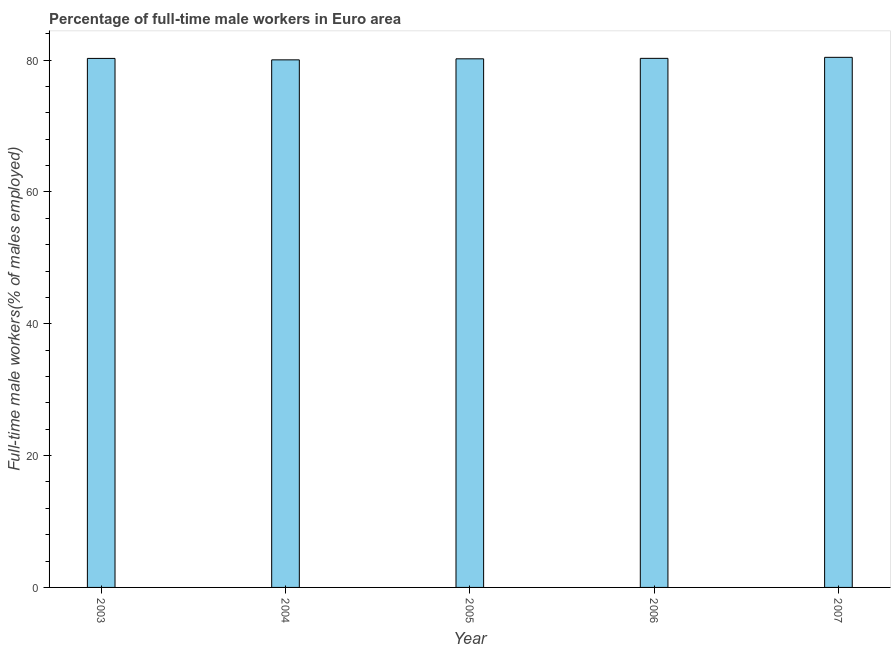What is the title of the graph?
Keep it short and to the point. Percentage of full-time male workers in Euro area. What is the label or title of the X-axis?
Keep it short and to the point. Year. What is the label or title of the Y-axis?
Your answer should be very brief. Full-time male workers(% of males employed). What is the percentage of full-time male workers in 2005?
Offer a very short reply. 80.19. Across all years, what is the maximum percentage of full-time male workers?
Provide a succinct answer. 80.42. Across all years, what is the minimum percentage of full-time male workers?
Give a very brief answer. 80.04. In which year was the percentage of full-time male workers maximum?
Make the answer very short. 2007. What is the sum of the percentage of full-time male workers?
Make the answer very short. 401.17. What is the difference between the percentage of full-time male workers in 2004 and 2007?
Make the answer very short. -0.38. What is the average percentage of full-time male workers per year?
Your answer should be compact. 80.23. What is the median percentage of full-time male workers?
Your response must be concise. 80.26. In how many years, is the percentage of full-time male workers greater than 68 %?
Give a very brief answer. 5. Do a majority of the years between 2007 and 2004 (inclusive) have percentage of full-time male workers greater than 80 %?
Your answer should be very brief. Yes. What is the ratio of the percentage of full-time male workers in 2003 to that in 2004?
Offer a very short reply. 1. Is the difference between the percentage of full-time male workers in 2006 and 2007 greater than the difference between any two years?
Give a very brief answer. No. What is the difference between the highest and the second highest percentage of full-time male workers?
Offer a terse response. 0.15. Is the sum of the percentage of full-time male workers in 2004 and 2007 greater than the maximum percentage of full-time male workers across all years?
Make the answer very short. Yes. What is the difference between the highest and the lowest percentage of full-time male workers?
Offer a terse response. 0.38. In how many years, is the percentage of full-time male workers greater than the average percentage of full-time male workers taken over all years?
Your answer should be compact. 3. Are all the bars in the graph horizontal?
Provide a short and direct response. No. What is the difference between two consecutive major ticks on the Y-axis?
Provide a short and direct response. 20. What is the Full-time male workers(% of males employed) of 2003?
Your response must be concise. 80.26. What is the Full-time male workers(% of males employed) of 2004?
Your answer should be very brief. 80.04. What is the Full-time male workers(% of males employed) of 2005?
Your answer should be compact. 80.19. What is the Full-time male workers(% of males employed) of 2006?
Provide a succinct answer. 80.27. What is the Full-time male workers(% of males employed) of 2007?
Keep it short and to the point. 80.42. What is the difference between the Full-time male workers(% of males employed) in 2003 and 2004?
Your answer should be compact. 0.22. What is the difference between the Full-time male workers(% of males employed) in 2003 and 2005?
Your response must be concise. 0.06. What is the difference between the Full-time male workers(% of males employed) in 2003 and 2006?
Your response must be concise. -0.01. What is the difference between the Full-time male workers(% of males employed) in 2003 and 2007?
Offer a very short reply. -0.16. What is the difference between the Full-time male workers(% of males employed) in 2004 and 2005?
Make the answer very short. -0.16. What is the difference between the Full-time male workers(% of males employed) in 2004 and 2006?
Give a very brief answer. -0.23. What is the difference between the Full-time male workers(% of males employed) in 2004 and 2007?
Your answer should be compact. -0.38. What is the difference between the Full-time male workers(% of males employed) in 2005 and 2006?
Ensure brevity in your answer.  -0.07. What is the difference between the Full-time male workers(% of males employed) in 2005 and 2007?
Keep it short and to the point. -0.23. What is the difference between the Full-time male workers(% of males employed) in 2006 and 2007?
Keep it short and to the point. -0.15. What is the ratio of the Full-time male workers(% of males employed) in 2003 to that in 2005?
Ensure brevity in your answer.  1. What is the ratio of the Full-time male workers(% of males employed) in 2003 to that in 2006?
Keep it short and to the point. 1. What is the ratio of the Full-time male workers(% of males employed) in 2004 to that in 2007?
Your response must be concise. 0.99. What is the ratio of the Full-time male workers(% of males employed) in 2005 to that in 2007?
Keep it short and to the point. 1. What is the ratio of the Full-time male workers(% of males employed) in 2006 to that in 2007?
Your response must be concise. 1. 